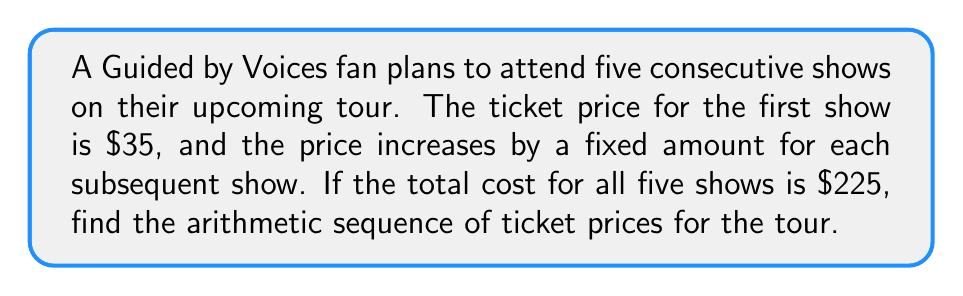Solve this math problem. Let's approach this step-by-step:

1) Let $a$ be the first term (price of the first show) and $d$ be the common difference (price increase per show).

2) We know that $a = 35$ (given in the question).

3) The arithmetic sequence will be: $35, 35+d, 35+2d, 35+3d, 35+4d$

4) The sum of an arithmetic sequence is given by the formula:
   $$S_n = \frac{n}{2}(a_1 + a_n)$$
   where $S_n$ is the sum, $n$ is the number of terms, $a_1$ is the first term, and $a_n$ is the last term.

5) In this case:
   $S_5 = 225$
   $n = 5$
   $a_1 = 35$
   $a_5 = 35 + 4d$

6) Substituting into the formula:
   $$225 = \frac{5}{2}(35 + (35 + 4d))$$

7) Simplifying:
   $$225 = \frac{5}{2}(70 + 4d)$$
   $$225 = 175 + 10d$$

8) Solving for $d$:
   $$50 = 10d$$
   $$d = 5$$

9) Now we can construct the full sequence:
   $35, 40, 45, 50, 55$

This arithmetic sequence represents the ticket prices for the five consecutive shows.
Answer: $35, 40, 45, 50, 55$ 